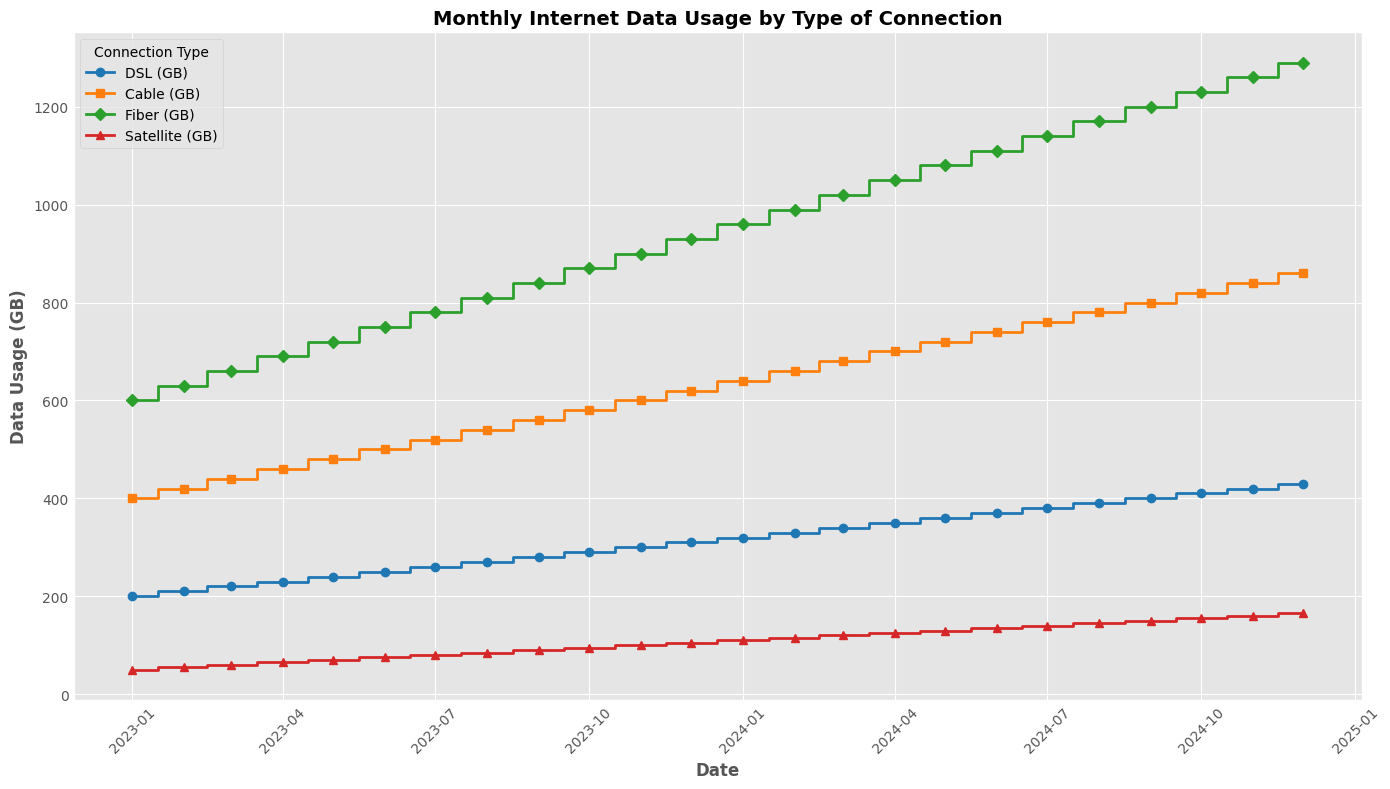What's the maximum data usage for Fiber (GB) throughout the period? The plot shows the monthly data usage for different connections. The highest point on the Fiber (GB) line indicates the maximum data usage. The highest value for Fiber (GB) is 1290 GB, which occurs in December 2024.
Answer: 1290 Between DSL (GB) and Satellite (GB), which one had a higher data usage in January 2023? We look at the data points for both DSL (GB) and Satellite (GB) in January 2023. The DSL (GB) usage is at 200 GB, and Satellite (GB) is at 50 GB. Thus, DSL (GB) had a higher data usage.
Answer: DSL (GB) What is the difference in data usage between Cable (GB) and Fiber (GB) in December 2024? In December 2024, we read the values for both Cable (GB) and Fiber (GB). Cable (GB) is at 860 GB, and Fiber (GB) is at 1290 GB. The difference is 1290 GB - 860 GB = 430 GB.
Answer: 430 Which connection type has shown the most significant increase in data usage from January 2023 to December 2024? To determine this, we compare the increase for each connection by subtracting the January 2023 values from the December 2024 values. 
- DSL: 430 GB - 200 GB = 230 GB
- Cable: 860 GB - 400 GB = 460 GB
- Fiber: 1290 GB - 600 GB = 690 GB
- Satellite: 165 GB - 50 GB = 115 GB
Fiber (GB) has the most significant increase with a 690 GB rise.
Answer: Fiber (GB) What can you say about the trend of monthly internet data usage for all types of connections? Observing the plot, all connection types show an upward trend in their data usage over the given time period. This indicates an overall increase in internet usage across all types of connections.
Answer: Increasing Which month had the lowest data usage for Satellite and what was the value? To find the lowest point on the Satellite (GB) line, we locate the lowest step, which occurs in January 2023 with a data usage value of 50 GB.
Answer: January 2023, 50 What was the total data usage in March 2024 for all connection types combined? We sum the data usage of all connection types in March 2024:
- DSL: 340 GB
- Cable: 680 GB
- Fiber: 1020 GB
- Satellite: 120 GB
The total is 340 + 680 + 1020 + 120 = 2160 GB.
Answer: 2160 In which month did all connection types exceed 300 GB in data usage? We check the plot for each connection type to see when all of them individually exceeded 300 GB. The first month this occurs is December 2024.
Answer: December 2024 How did the data usage for Fiber (GB) change from August 2023 to August 2024? We find the data usage for Fiber (GB) in both months. In August 2023, it is 810 GB. In August 2024, it is 1170 GB. The change is 1170 GB - 810 GB = 360 GB.
Answer: Increased by 360 Is there any month where DSL and Cable had the same data usage? Observing the steps on the plot, we look for any month where the DSL (GB) line intersects with the Cable (GB) line at the same value. There is no such month where both DSL and Cable have the same usage values.
Answer: No 